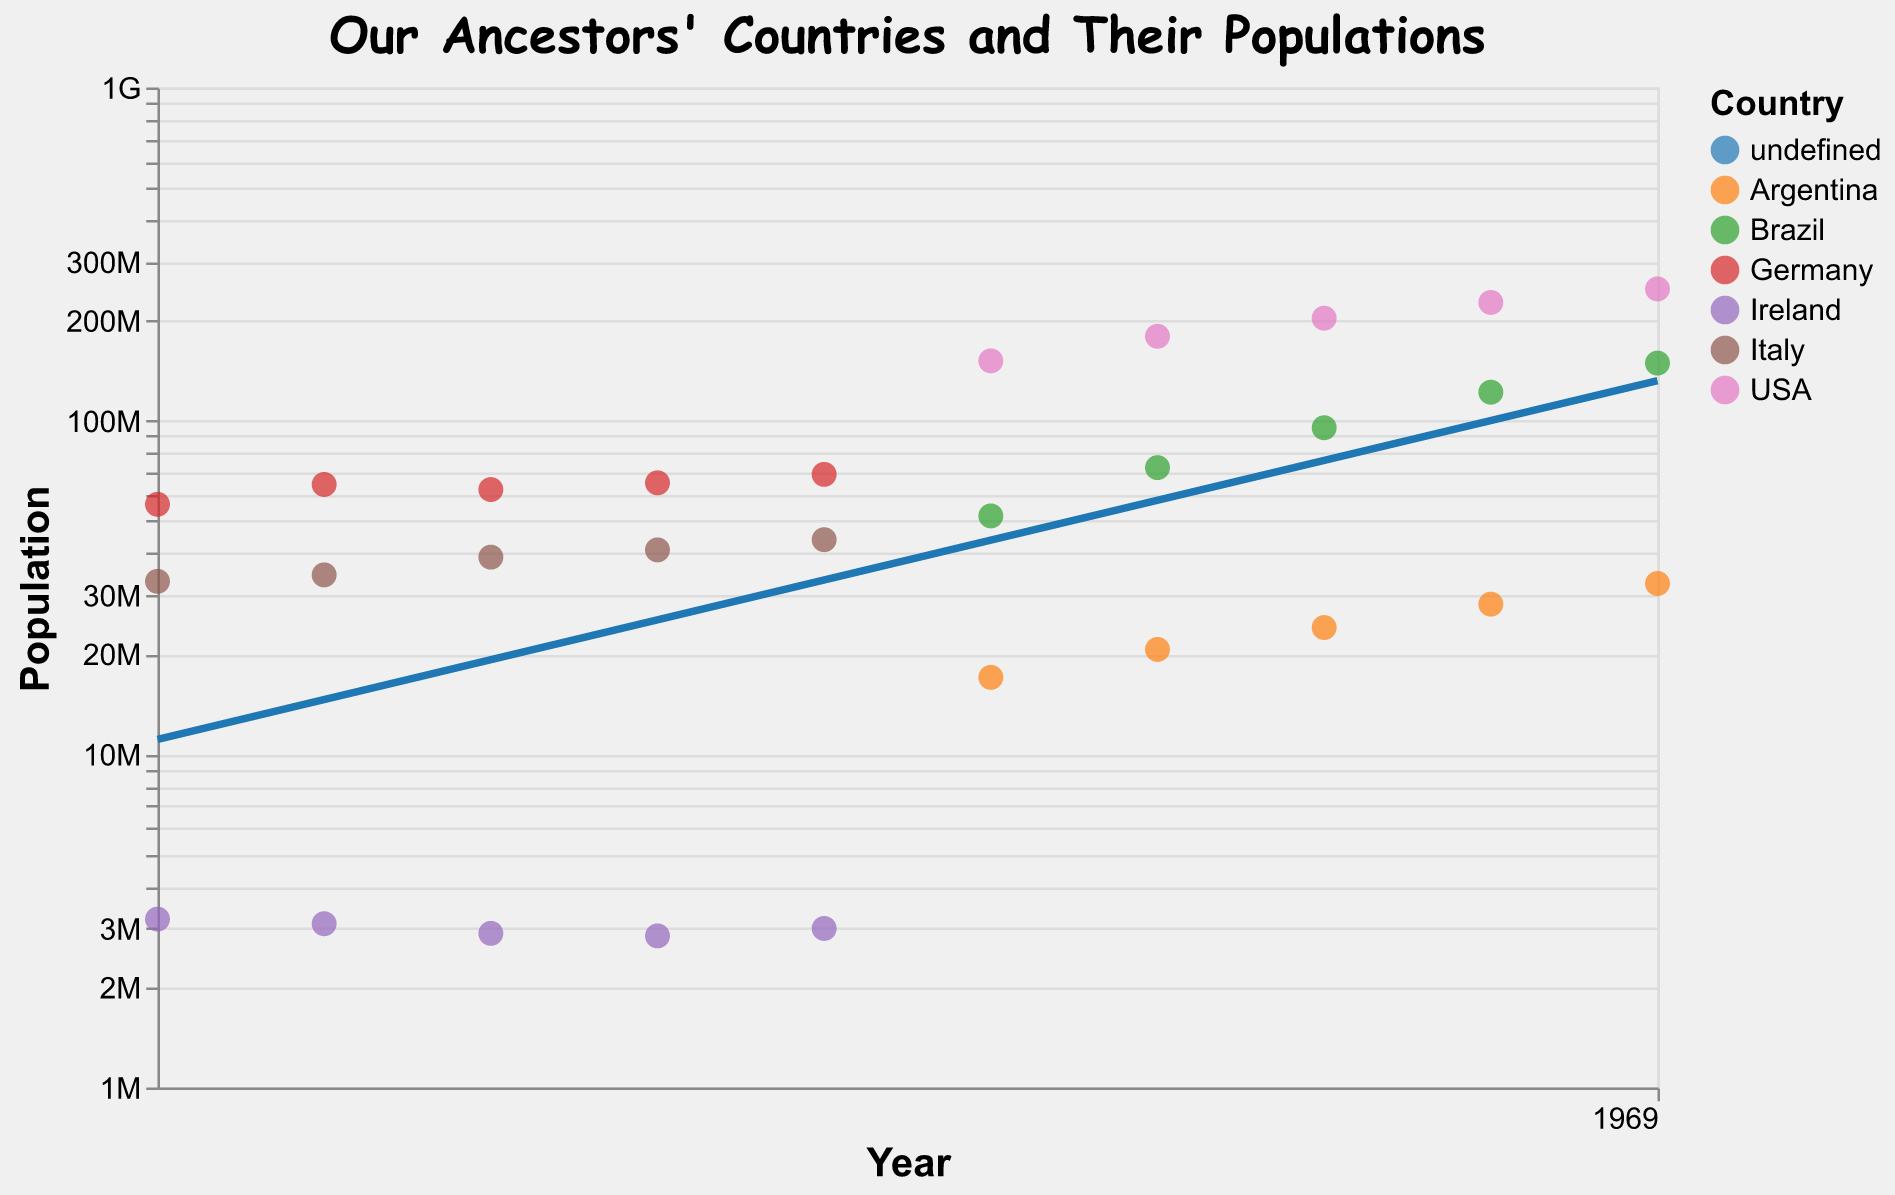What is the title of the figure? The title is displayed at the top middle of the figure and reads "Our Ancestors' Countries and Their Populations."
Answer: Our Ancestors' Countries and Their Populations Which country has the highest population in 1990? By examining the data points for 1990, the USA has the highest population, reaching 248,709,873.
Answer: USA How has Italy's population changed from 1900 to 1940? Looking at the trend line for Italy, the population increased from 33,000,000 in 1900 to 44,000,000 in 1940. The increase is calculated as 44,000,000 - 33,000,000 = 11,000,000.
Answer: Increased by 11,000,000 Which country had a decreasing population from 1900 to 1920? By comparing the data points, Ireland is the only country that had a decrease, from 3,200,000 in 1900 to 2,900,000 in 1920.
Answer: Ireland What is the trend line's color for Argentina? The color legend identifies Argentina with a specific color. By matching the trend line to the legend, Argentina's trend line color is identified.
Answer: Identified via the color legend How does the population growth of Brazil compare to that of Germany between 1950 and 1990? Evaluating the change for Brazil from 51,848,438 in 1950 to 149,003,225 in 1990 (an increase of 97,154,787) and Germany from 69,080,000 in 1940 to 69,080,000 in 1990 (no change due to the missing data in 1950), Brazil shows much higher growth.
Answer: Brazil's growth is significantly higher What is the average population of Italy from 1900 to 1940? Calculate the population values for Italy: (33,000,000 + 34,500,000 + 39,000,000 + 41,000,000 + 44,000,000) = 191,500,000. Then get the average: 191,500,000 / 5 = 38,300,000.
Answer: 38,300,000 How many countries are represented in the figure? By identifying unique entries in the legend, there are five listed: Italy, USA, Germany, Brazil, Argentina, and Ireland.
Answer: 6 countries What does the Y-axis represent? The Y-axis is labeled "Population," indicating it represents population values using a log scale.
Answer: Population Which country had the lowest population in 1900? By reviewing the data points for 1900, Ireland had the lowest population at 3,200,000.
Answer: Ireland 